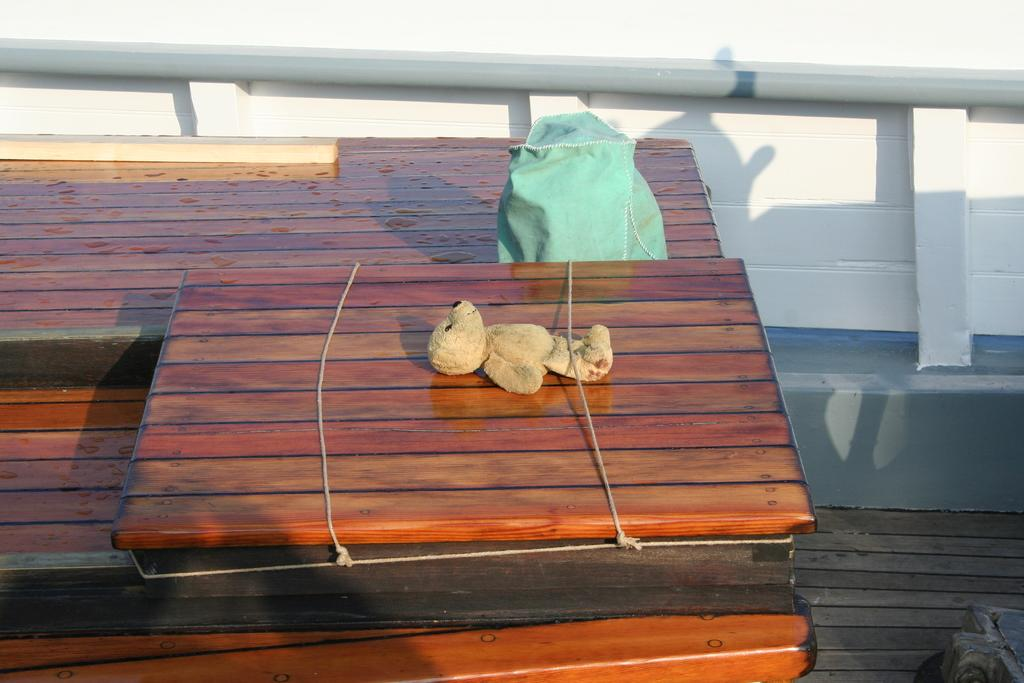What is the main object in the image? There is a wooden block in the image. How is the toy connected to the wooden block? A toy is tied to the wooden block with a rope. What else can be seen in the image besides the wooden block and toy? There is a packet in the image. What is visible in the background of the image? There is a wall in the background of the image. How many mines are visible in the image? There are no mines present in the image. What type of fowl can be seen perched on the wooden block in the image? There is no fowl present in the image; it only features a wooden block, a toy, and a rope. 